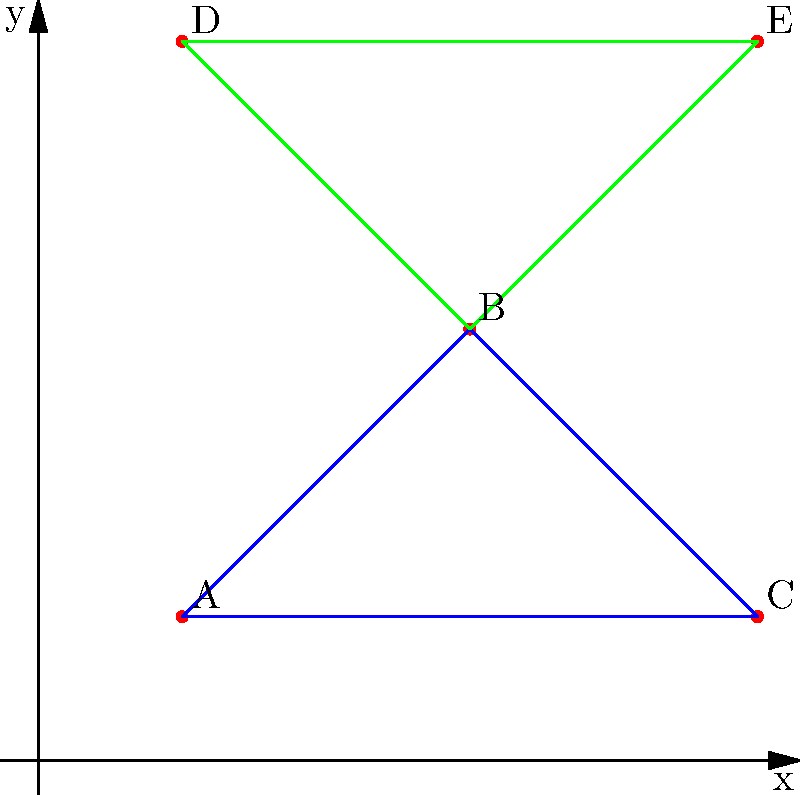In a coordinate plane, five design elements (A, B, C, D, and E) are placed to create a repeating pattern for a screen-printed fabric design. The coordinates of these elements are A(1,1), B(3,3), C(5,1), D(1,5), and E(5,5). Two triangles are formed: ABC (blue) and BDE (green). Calculate the total area covered by both triangles to determine the size of the repeating pattern unit. To find the total area, we need to calculate the areas of both triangles and sum them up:

1. For triangle ABC:
   Base = AC = $\sqrt{(5-1)^2 + (1-1)^2} = 4$
   Height = perpendicular distance from B to AC
   Height = $\frac{|3(5-1) + 3(1-1) + 1(1-5)|}{\sqrt{(5-1)^2 + (1-1)^2}} = 2$
   Area of ABC = $\frac{1}{2} \times 4 \times 2 = 4$ square units

2. For triangle BDE:
   Base = DE = $\sqrt{(5-1)^2 + (5-5)^2} = 4$
   Height = perpendicular distance from B to DE
   Height = $\frac{|5(3-5) + 5(3-1) + 3(1-5)|}{\sqrt{(5-1)^2 + (5-5)^2}} = 2$
   Area of BDE = $\frac{1}{2} \times 4 \times 2 = 4$ square units

3. Total area:
   Total area = Area of ABC + Area of BDE
               = 4 + 4 = 8 square units
Answer: 8 square units 